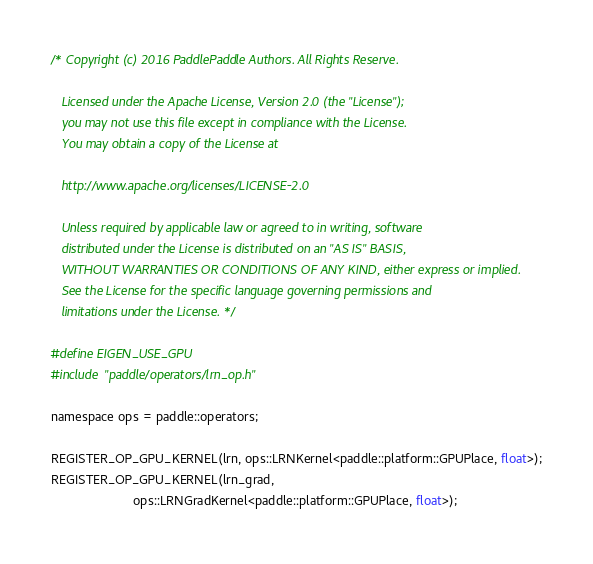Convert code to text. <code><loc_0><loc_0><loc_500><loc_500><_Cuda_>/* Copyright (c) 2016 PaddlePaddle Authors. All Rights Reserve.

   Licensed under the Apache License, Version 2.0 (the "License");
   you may not use this file except in compliance with the License.
   You may obtain a copy of the License at

   http://www.apache.org/licenses/LICENSE-2.0

   Unless required by applicable law or agreed to in writing, software
   distributed under the License is distributed on an "AS IS" BASIS,
   WITHOUT WARRANTIES OR CONDITIONS OF ANY KIND, either express or implied.
   See the License for the specific language governing permissions and
   limitations under the License. */

#define EIGEN_USE_GPU
#include "paddle/operators/lrn_op.h"

namespace ops = paddle::operators;

REGISTER_OP_GPU_KERNEL(lrn, ops::LRNKernel<paddle::platform::GPUPlace, float>);
REGISTER_OP_GPU_KERNEL(lrn_grad,
                       ops::LRNGradKernel<paddle::platform::GPUPlace, float>);
</code> 